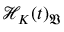Convert formula to latex. <formula><loc_0><loc_0><loc_500><loc_500>\mathcal { H } _ { K } ( t ) _ { \mathfrak { V } }</formula> 